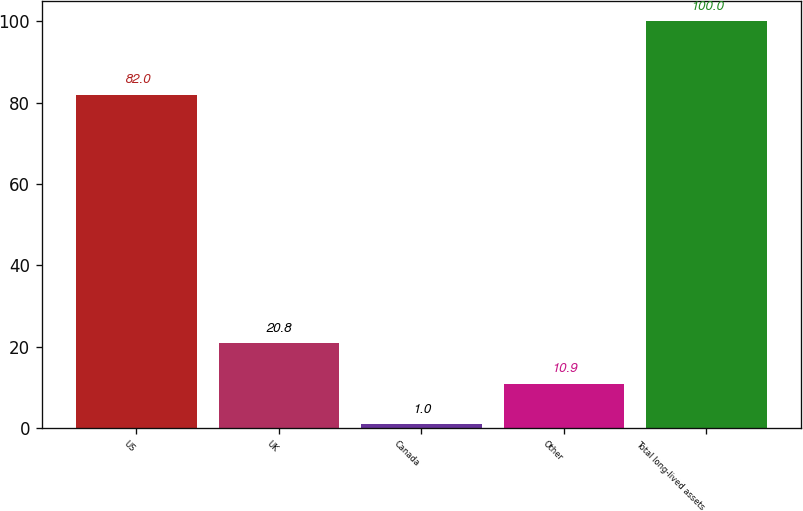<chart> <loc_0><loc_0><loc_500><loc_500><bar_chart><fcel>US<fcel>UK<fcel>Canada<fcel>Other<fcel>Total long-lived assets<nl><fcel>82<fcel>20.8<fcel>1<fcel>10.9<fcel>100<nl></chart> 